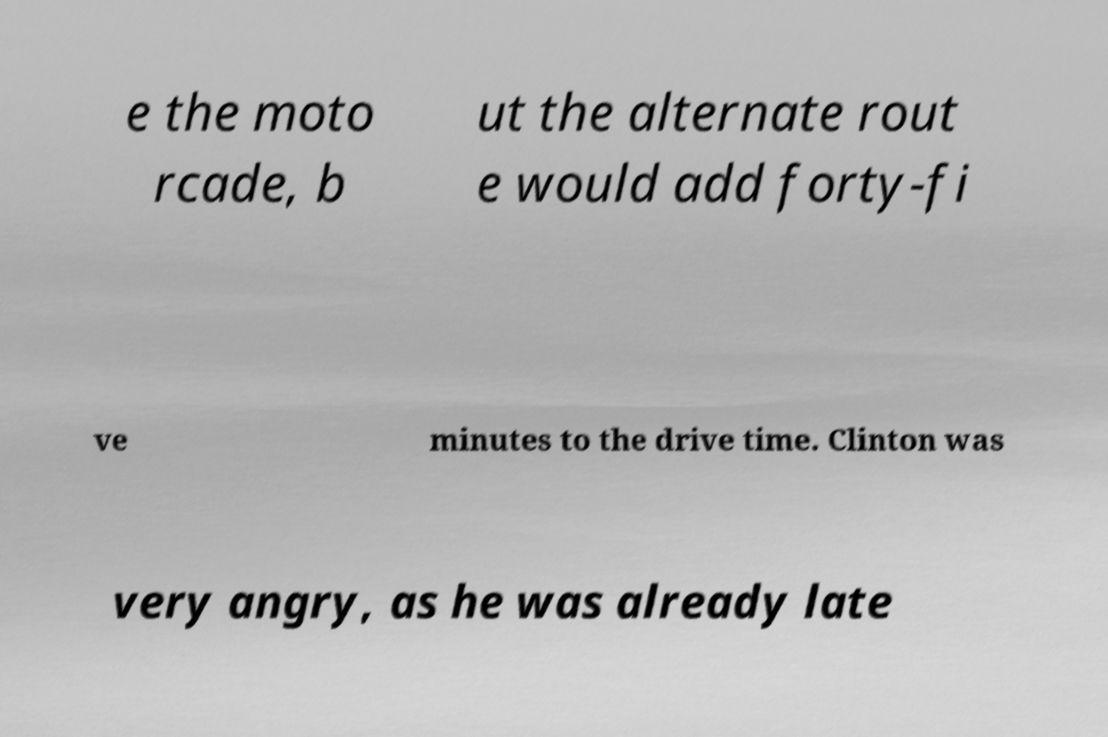What messages or text are displayed in this image? I need them in a readable, typed format. e the moto rcade, b ut the alternate rout e would add forty-fi ve minutes to the drive time. Clinton was very angry, as he was already late 